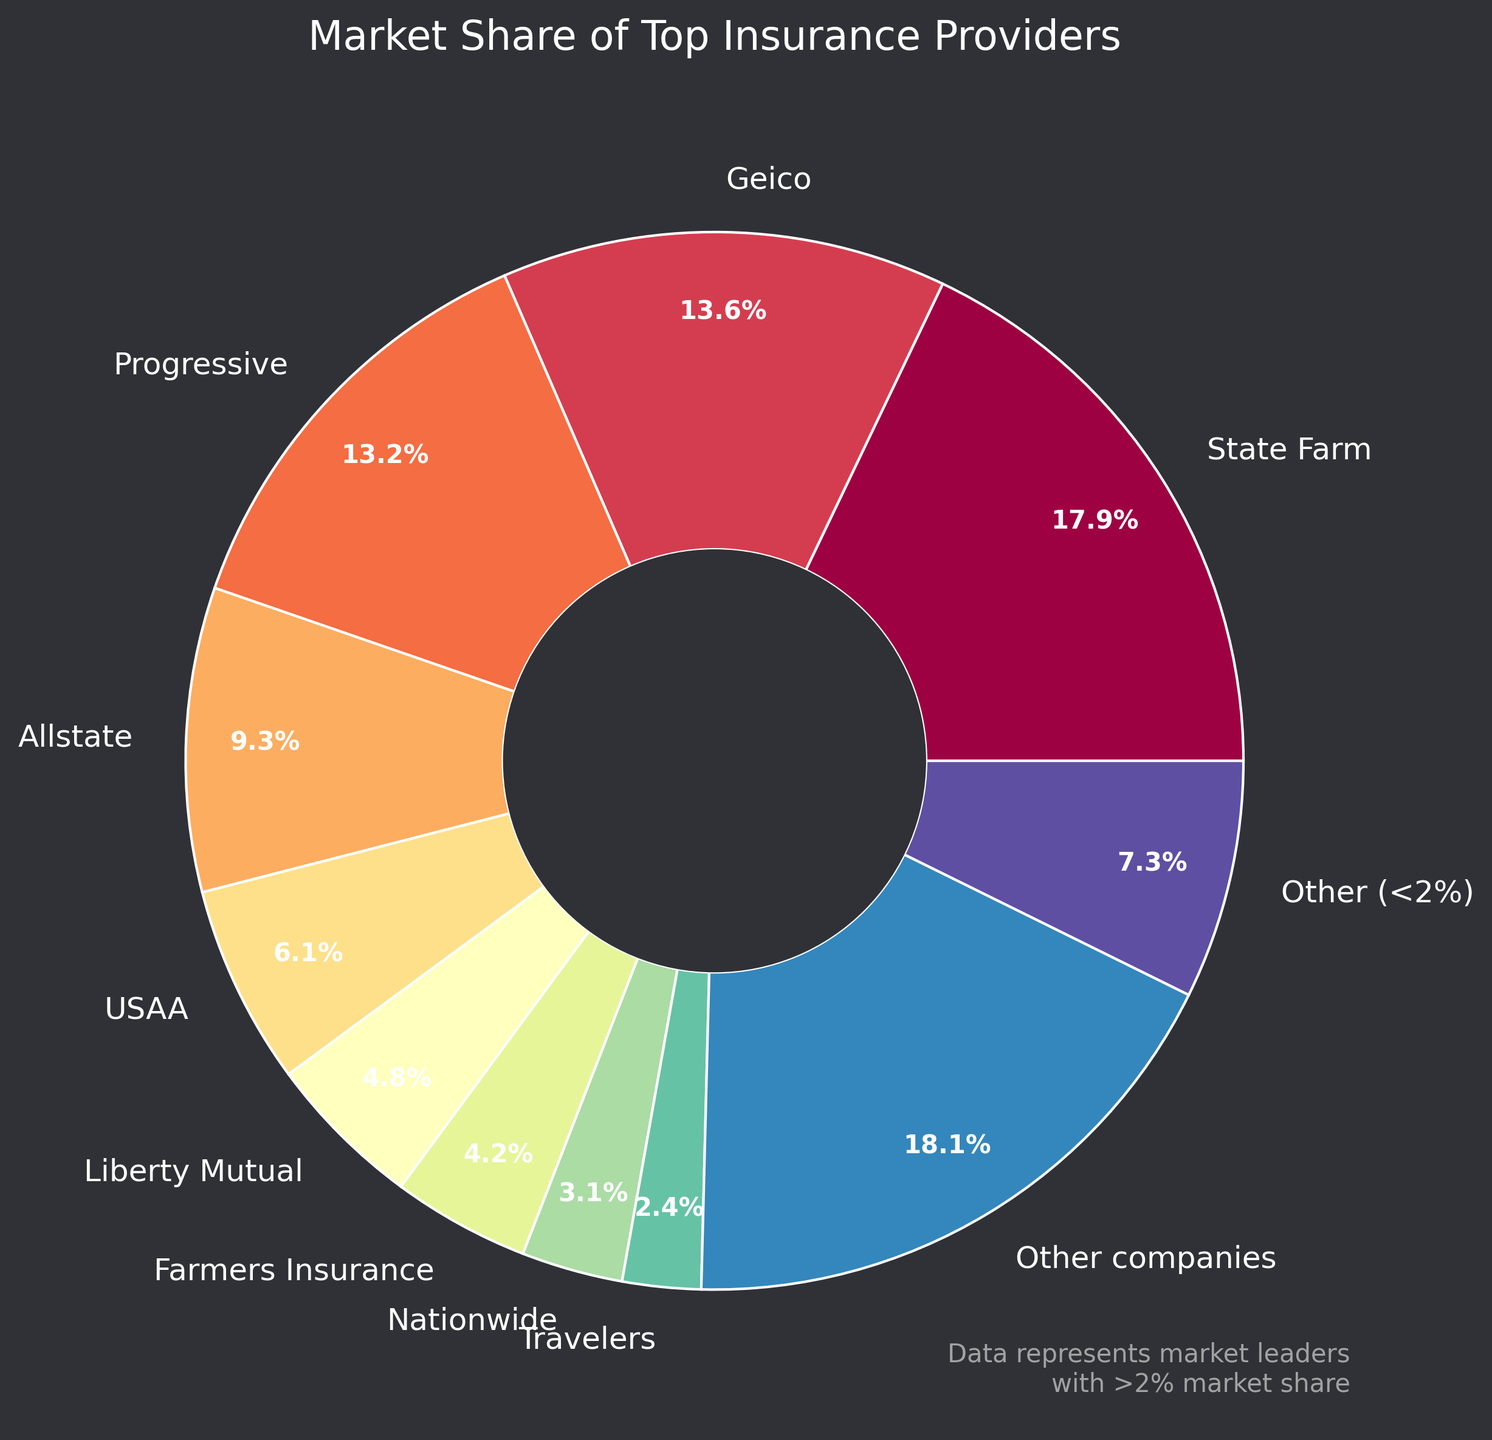What percentage of the market do the top three companies hold together? State Farm (17.9%), Geico (13.6%), and Progressive (13.2%) are the top three companies. Adding their market shares gives 17.9 + 13.6 + 13.2 = 44.7%
Answer: 44.7% Which company has the lowest market share among those explicitly listed, and what is its share? MetLife has the lowest market share among the listed companies with 0.8%
Answer: MetLife, 0.8% How much more market share does State Farm have compared to Progressive? State Farm’s market share is 17.9%, and Progressive’s market share is 13.2%. The difference is 17.9 - 13.2 = 4.7%
Answer: 4.7% What is the combined market share of companies with less than 2% market share? The figure lists a combined segment 'Other (<2%)' representing companies with individual market shares less than 2%, and this segment holds 18.1%
Answer: 18.1% How many companies have a market share greater than 10%? The companies with more than 10% market share are State Farm (17.9%), Geico (13.6%), and Progressive (13.2%). There are 3 such companies
Answer: 3 What is the visual distinction used to highlight companies with a market share of 2% or greater? Companies with a market share of 2% or greater are labeled individually on the chart, while those with less than 2% are grouped into a segment labeled 'Other (<2%)' with a distinct color
Answer: Individual labels and distinct color for 'Other (<2%)' Calculate the difference in total market share between the top-ranking company (State Farm) and the company ranked fifth (USAA). State Farm has a market share of 17.9%, and USAA has 6.1%. The difference is 17.9 - 6.1 = 11.8%
Answer: 11.8% Is there a bigger market share gap between State Farm and Geico or between Geico and Progressive? State Farm (17.9%) vs. Geico (13.6%) has a gap of 17.9 - 13.6 = 4.3%; Geico (13.6%) vs. Progressive (13.2%) has a gap of 13.6 - 13.2 = 0.4%. Therefore, the bigger gap is between State Farm and Geico
Answer: State Farm vs. Geico Which company shares a similar market share size with Allstate? Allstate has a market share of 9.3%. Progressive is closely behind with a market share of 13.2%. However, USAA is the next closest, but with a larger deviation (6.1%). So, Progressive is the closest in size among significant competitors
Answer: Progressive What is the total market share percentage of the companies occupying 4th to 6th positions? Allstate (9.3%), USAA (6.1%), and Liberty Mutual (4.8%) are in the 4th to 6th positions. Adding their shares gives 9.3 + 6.1 + 4.8 = 20.2%
Answer: 20.2% 